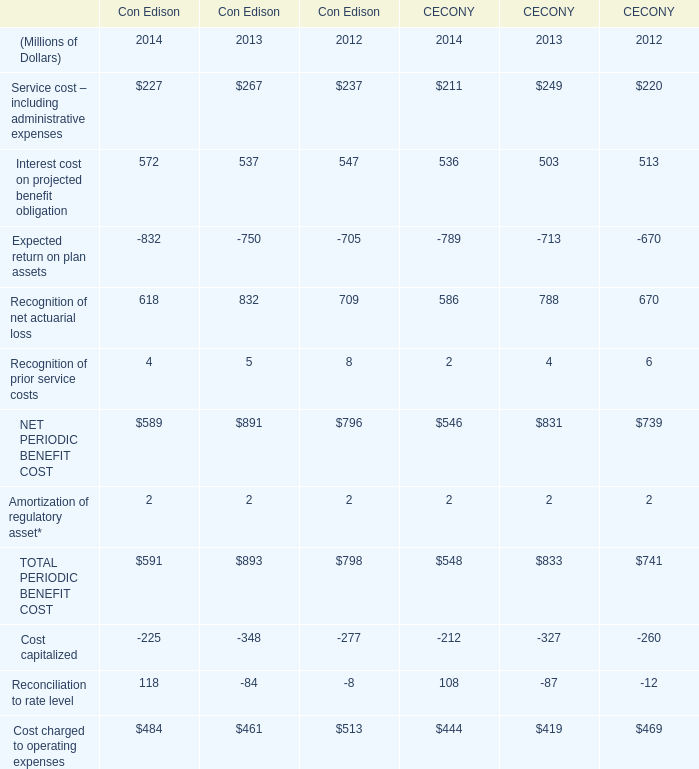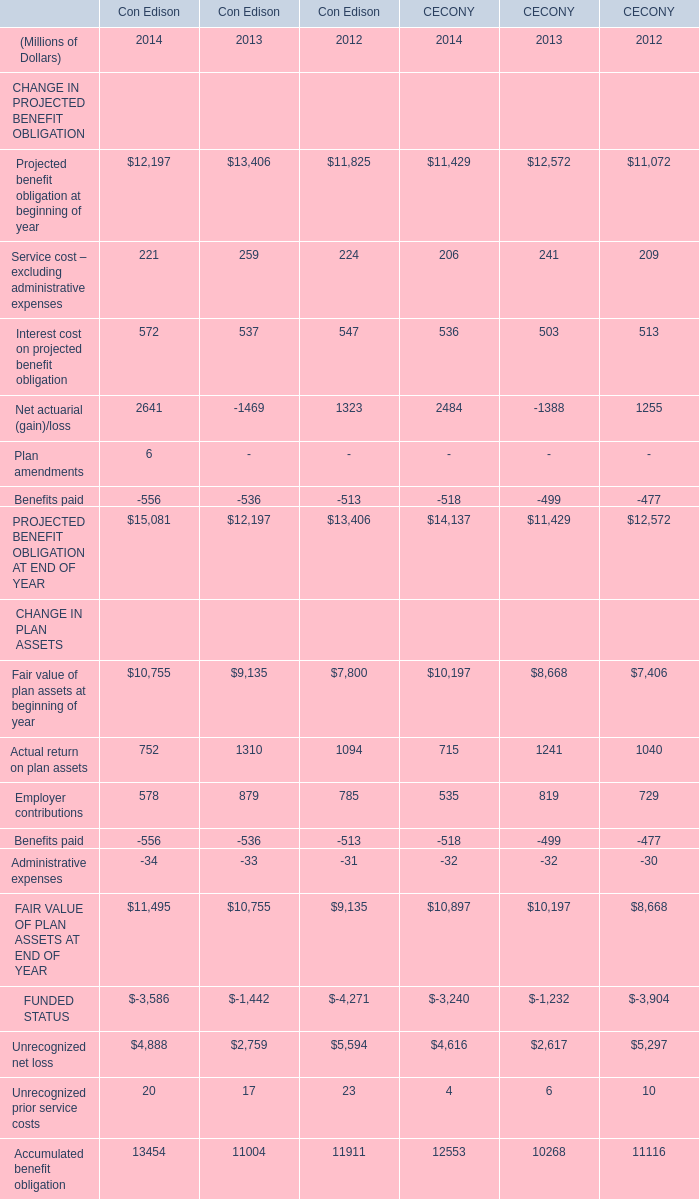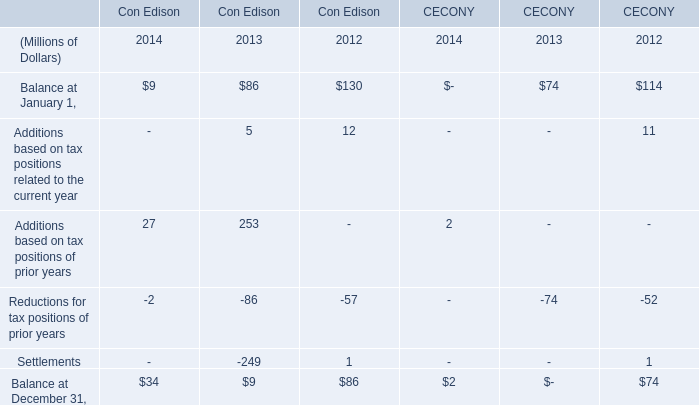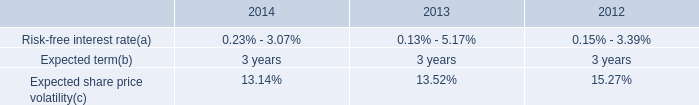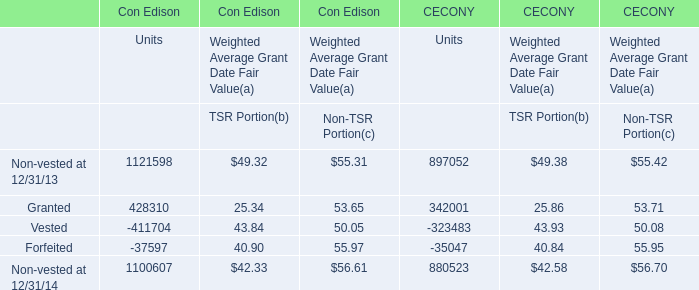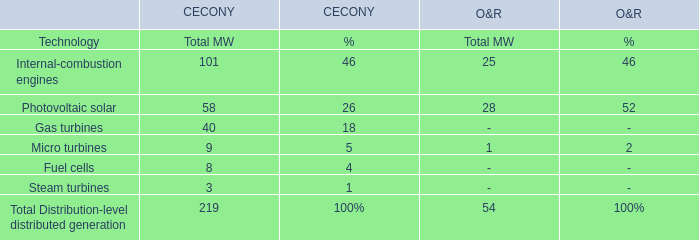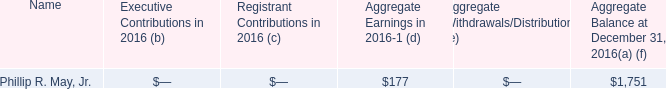What's the sum of Granted of Con Edison Units, FUNDED STATUS CHANGE IN PLAN ASSETS of Con Edison 2014, and FUNDED STATUS CHANGE IN PLAN ASSETS of CECONY 2012 ? 
Computations: ((428310.0 + 3586.0) + 3904.0)
Answer: 435800.0. 